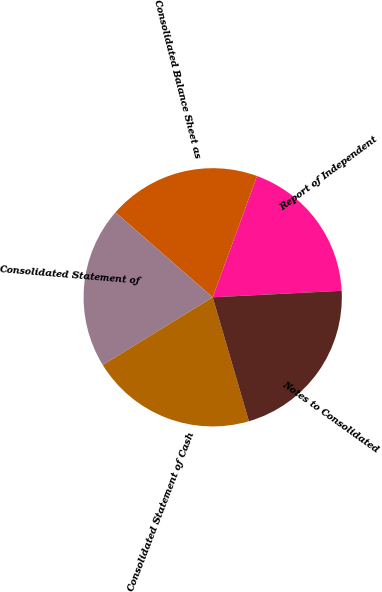Convert chart to OTSL. <chart><loc_0><loc_0><loc_500><loc_500><pie_chart><fcel>Report of Independent<fcel>Consolidated Balance Sheet as<fcel>Consolidated Statement of<fcel>Consolidated Statement of Cash<fcel>Notes to Consolidated<nl><fcel>18.62%<fcel>19.15%<fcel>20.21%<fcel>20.74%<fcel>21.28%<nl></chart> 